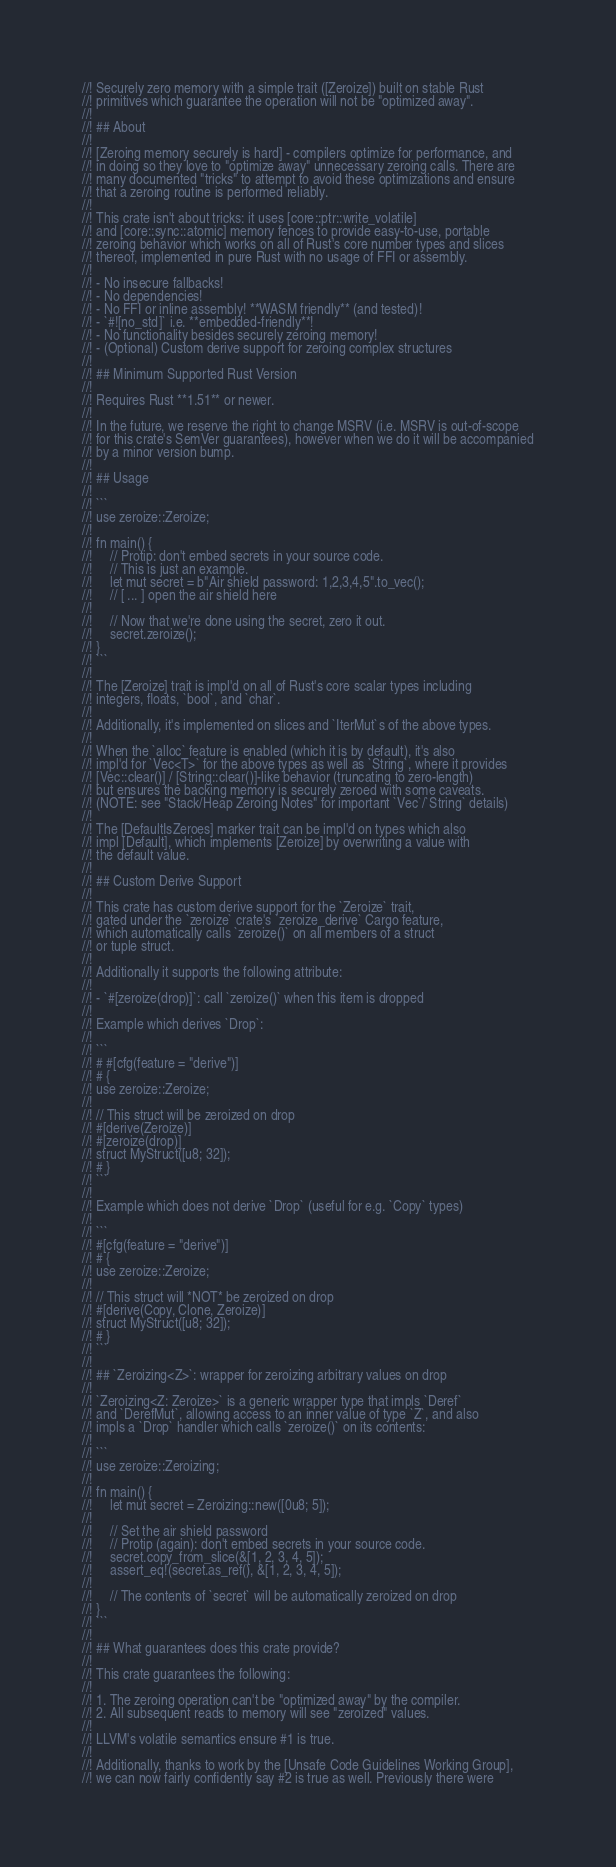<code> <loc_0><loc_0><loc_500><loc_500><_Rust_>//! Securely zero memory with a simple trait ([Zeroize]) built on stable Rust
//! primitives which guarantee the operation will not be "optimized away".
//!
//! ## About
//!
//! [Zeroing memory securely is hard] - compilers optimize for performance, and
//! in doing so they love to "optimize away" unnecessary zeroing calls. There are
//! many documented "tricks" to attempt to avoid these optimizations and ensure
//! that a zeroing routine is performed reliably.
//!
//! This crate isn't about tricks: it uses [core::ptr::write_volatile]
//! and [core::sync::atomic] memory fences to provide easy-to-use, portable
//! zeroing behavior which works on all of Rust's core number types and slices
//! thereof, implemented in pure Rust with no usage of FFI or assembly.
//!
//! - No insecure fallbacks!
//! - No dependencies!
//! - No FFI or inline assembly! **WASM friendly** (and tested)!
//! - `#![no_std]` i.e. **embedded-friendly**!
//! - No functionality besides securely zeroing memory!
//! - (Optional) Custom derive support for zeroing complex structures
//!
//! ## Minimum Supported Rust Version
//!
//! Requires Rust **1.51** or newer.
//!
//! In the future, we reserve the right to change MSRV (i.e. MSRV is out-of-scope
//! for this crate's SemVer guarantees), however when we do it will be accompanied
//! by a minor version bump.
//!
//! ## Usage
//!
//! ```
//! use zeroize::Zeroize;
//!
//! fn main() {
//!     // Protip: don't embed secrets in your source code.
//!     // This is just an example.
//!     let mut secret = b"Air shield password: 1,2,3,4,5".to_vec();
//!     // [ ... ] open the air shield here
//!
//!     // Now that we're done using the secret, zero it out.
//!     secret.zeroize();
//! }
//! ```
//!
//! The [Zeroize] trait is impl'd on all of Rust's core scalar types including
//! integers, floats, `bool`, and `char`.
//!
//! Additionally, it's implemented on slices and `IterMut`s of the above types.
//!
//! When the `alloc` feature is enabled (which it is by default), it's also
//! impl'd for `Vec<T>` for the above types as well as `String`, where it provides
//! [Vec::clear()] / [String::clear()]-like behavior (truncating to zero-length)
//! but ensures the backing memory is securely zeroed with some caveats.
//! (NOTE: see "Stack/Heap Zeroing Notes" for important `Vec`/`String` details)
//!
//! The [DefaultIsZeroes] marker trait can be impl'd on types which also
//! impl [Default], which implements [Zeroize] by overwriting a value with
//! the default value.
//!
//! ## Custom Derive Support
//!
//! This crate has custom derive support for the `Zeroize` trait,
//! gated under the `zeroize` crate's `zeroize_derive` Cargo feature,
//! which automatically calls `zeroize()` on all members of a struct
//! or tuple struct.
//!
//! Additionally it supports the following attribute:
//!
//! - `#[zeroize(drop)]`: call `zeroize()` when this item is dropped
//!
//! Example which derives `Drop`:
//!
//! ```
//! # #[cfg(feature = "derive")]
//! # {
//! use zeroize::Zeroize;
//!
//! // This struct will be zeroized on drop
//! #[derive(Zeroize)]
//! #[zeroize(drop)]
//! struct MyStruct([u8; 32]);
//! # }
//! ```
//!
//! Example which does not derive `Drop` (useful for e.g. `Copy` types)
//!
//! ```
//! #[cfg(feature = "derive")]
//! # {
//! use zeroize::Zeroize;
//!
//! // This struct will *NOT* be zeroized on drop
//! #[derive(Copy, Clone, Zeroize)]
//! struct MyStruct([u8; 32]);
//! # }
//! ```
//!
//! ## `Zeroizing<Z>`: wrapper for zeroizing arbitrary values on drop
//!
//! `Zeroizing<Z: Zeroize>` is a generic wrapper type that impls `Deref`
//! and `DerefMut`, allowing access to an inner value of type `Z`, and also
//! impls a `Drop` handler which calls `zeroize()` on its contents:
//!
//! ```
//! use zeroize::Zeroizing;
//!
//! fn main() {
//!     let mut secret = Zeroizing::new([0u8; 5]);
//!
//!     // Set the air shield password
//!     // Protip (again): don't embed secrets in your source code.
//!     secret.copy_from_slice(&[1, 2, 3, 4, 5]);
//!     assert_eq!(secret.as_ref(), &[1, 2, 3, 4, 5]);
//!
//!     // The contents of `secret` will be automatically zeroized on drop
//! }
//! ```
//!
//! ## What guarantees does this crate provide?
//!
//! This crate guarantees the following:
//!
//! 1. The zeroing operation can't be "optimized away" by the compiler.
//! 2. All subsequent reads to memory will see "zeroized" values.
//!
//! LLVM's volatile semantics ensure #1 is true.
//!
//! Additionally, thanks to work by the [Unsafe Code Guidelines Working Group],
//! we can now fairly confidently say #2 is true as well. Previously there were</code> 